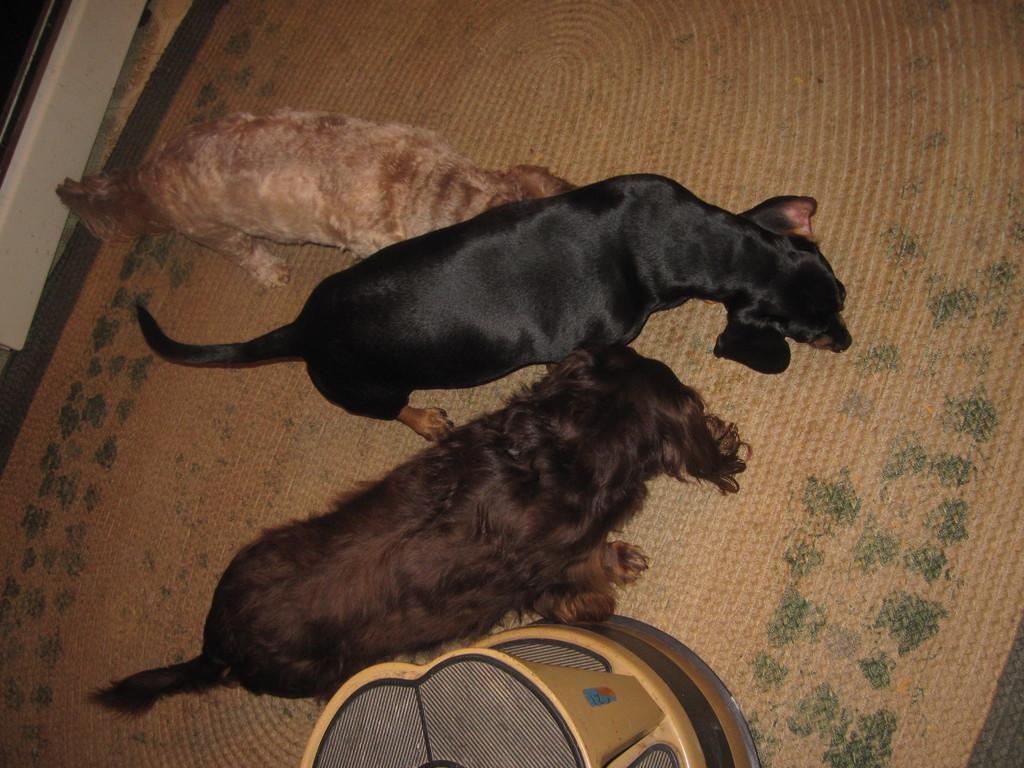Could you give a brief overview of what you see in this image? In the picture we can see a floor mat on it, we can see three dogs, one dog is cream and brownish in color and one dog is black in color and one dog is dark brown in color with full of fur in it and beside we can see some box which is some gold color to it. 